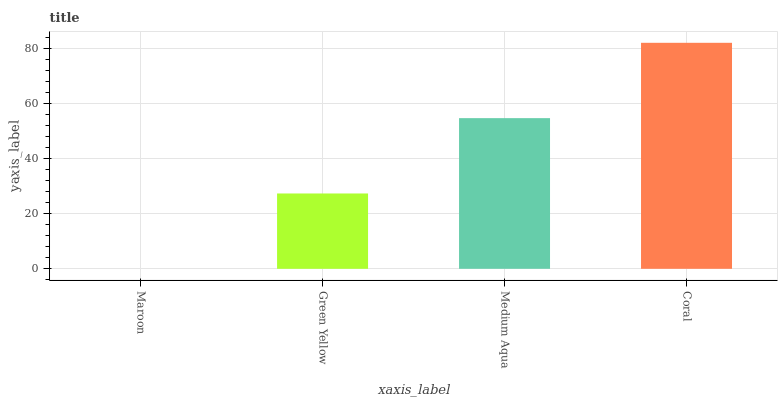Is Maroon the minimum?
Answer yes or no. Yes. Is Coral the maximum?
Answer yes or no. Yes. Is Green Yellow the minimum?
Answer yes or no. No. Is Green Yellow the maximum?
Answer yes or no. No. Is Green Yellow greater than Maroon?
Answer yes or no. Yes. Is Maroon less than Green Yellow?
Answer yes or no. Yes. Is Maroon greater than Green Yellow?
Answer yes or no. No. Is Green Yellow less than Maroon?
Answer yes or no. No. Is Medium Aqua the high median?
Answer yes or no. Yes. Is Green Yellow the low median?
Answer yes or no. Yes. Is Maroon the high median?
Answer yes or no. No. Is Medium Aqua the low median?
Answer yes or no. No. 